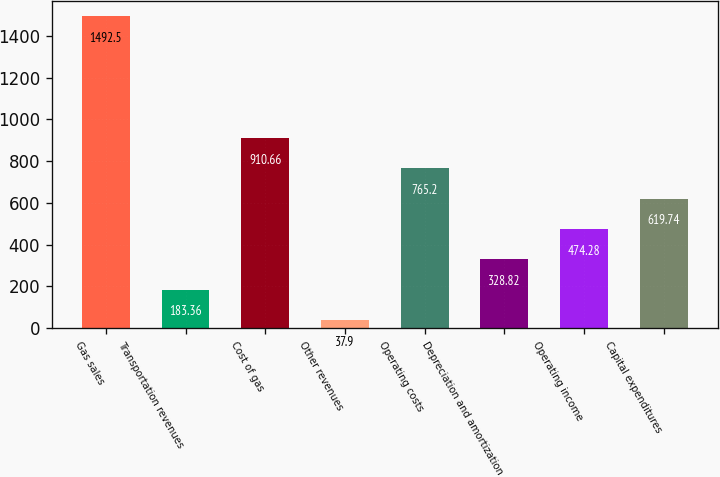Convert chart to OTSL. <chart><loc_0><loc_0><loc_500><loc_500><bar_chart><fcel>Gas sales<fcel>Transportation revenues<fcel>Cost of gas<fcel>Other revenues<fcel>Operating costs<fcel>Depreciation and amortization<fcel>Operating income<fcel>Capital expenditures<nl><fcel>1492.5<fcel>183.36<fcel>910.66<fcel>37.9<fcel>765.2<fcel>328.82<fcel>474.28<fcel>619.74<nl></chart> 